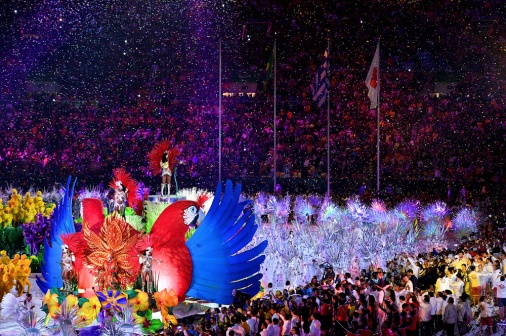What are the key elements in this picture? The image showcases a magnificent parade in a packed stadium. Central to the scene are two colossal bird-like floats: one radiates with warm shades of red and orange, akin to a Phoenix, with a person triumphantly standing atop it; the other is a majestic counterpart in cooling hues of blue and purple, reminiscent of a peacock, with an occupant seated above, seemingly overseeing the procession. These fantastical creatures, adorned with intricate feather patterns and towering above the surrounding participants dressed in floral and festive attire, suggest a theme of myth and nature. The spectators' grandstand alive with the glow of lights, feel the energy of the event through the myriad of colors, while confetti showers down, evoking a celebrative and spirited vibe. Flags and poles ripple above the crowd, creating a dynamic tapestry of movement and spectacle. Overall, the scene is awash with exuberance and could be part of a grand cultural or sports ceremony. 